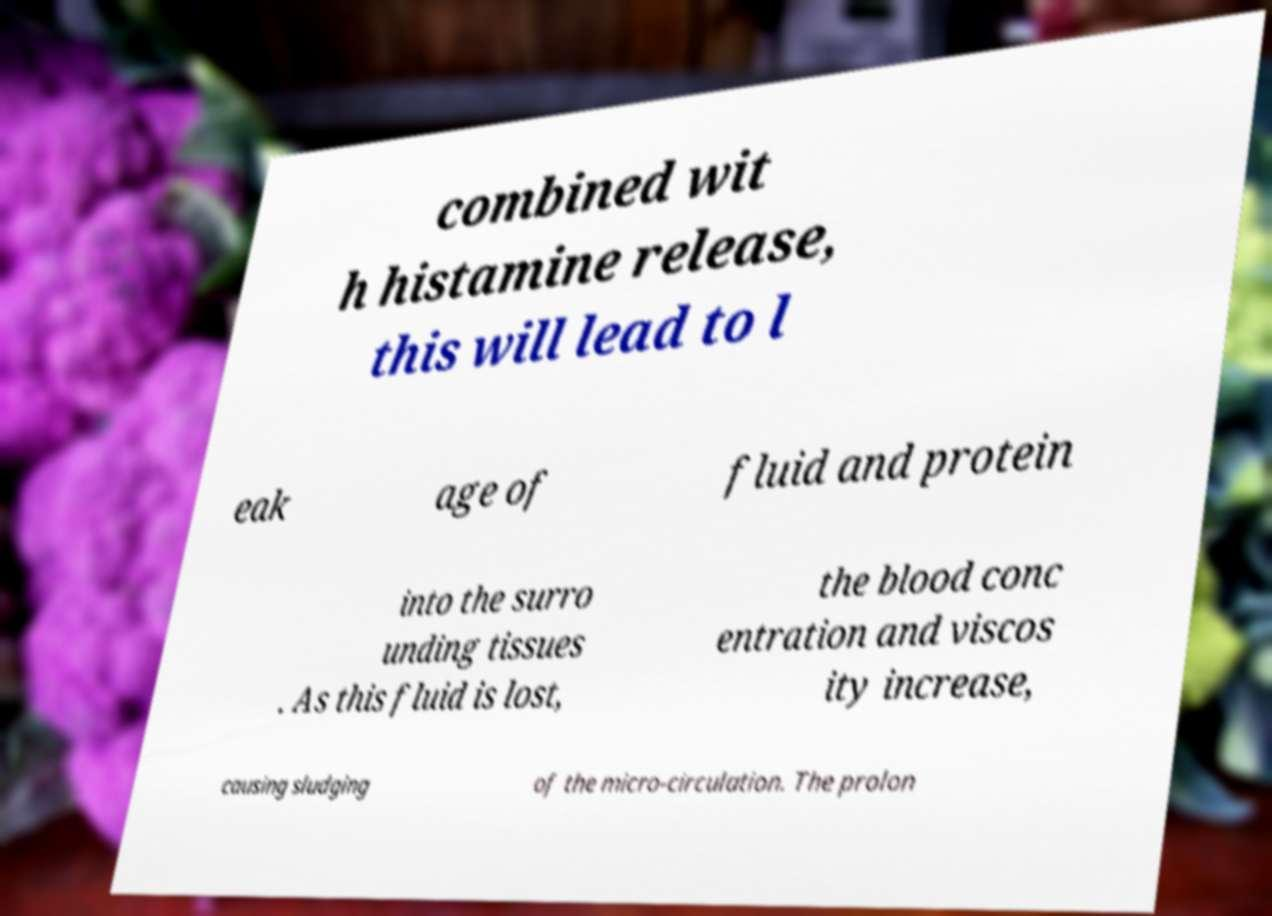There's text embedded in this image that I need extracted. Can you transcribe it verbatim? combined wit h histamine release, this will lead to l eak age of fluid and protein into the surro unding tissues . As this fluid is lost, the blood conc entration and viscos ity increase, causing sludging of the micro-circulation. The prolon 